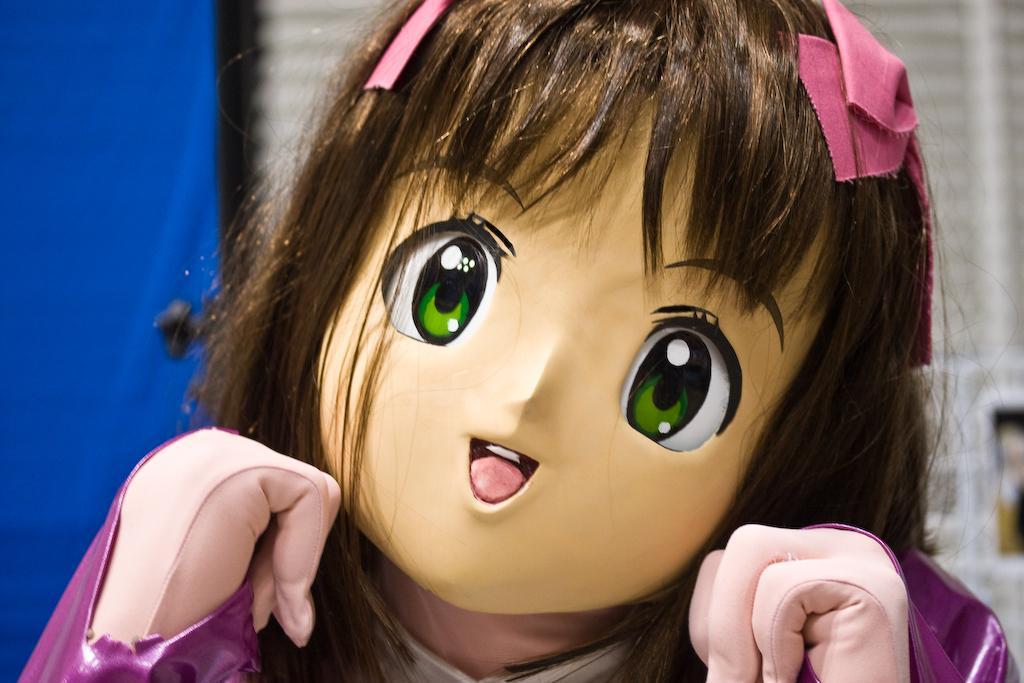Describe this image in one or two sentences. We can see doll. In the background it is white and blue color. 